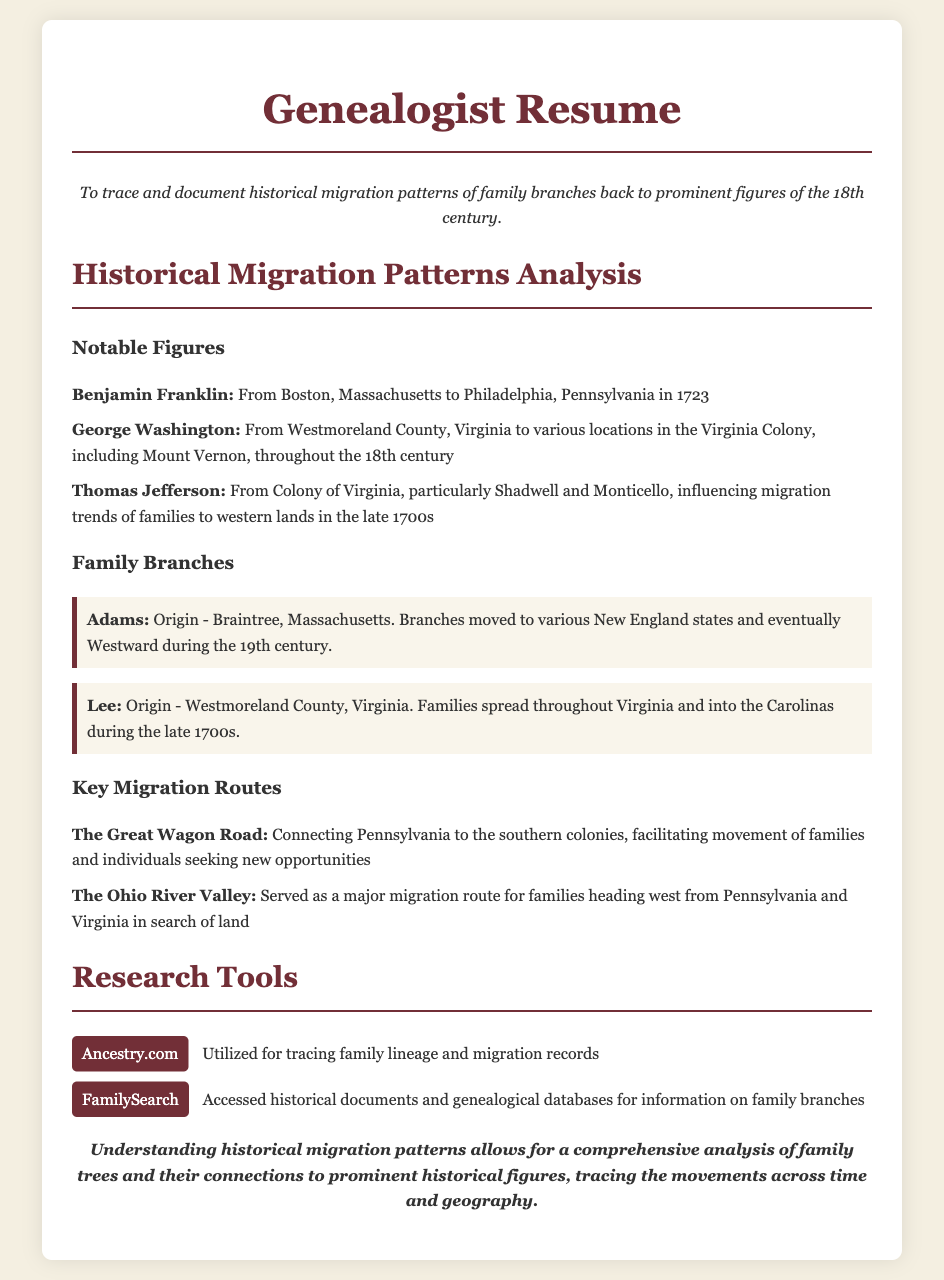what is the objective of the resume? The objective outlines the purpose of the resume, highlighting the genealogist's aim to trace and document historical migration patterns.
Answer: To trace and document historical migration patterns of family branches back to prominent figures of the 18th century who is mentioned as moving from Boston to Philadelphia? This information is specific to Benjamin Franklin, describing his migration path.
Answer: Benjamin Franklin which family branch originated from Braintree, Massachusetts? This question targets the origin of the Adams family, as noted in the document.
Answer: Adams what route connected Pennsylvania to the southern colonies? The question refers to a key migration route mentioned, providing historical context.
Answer: The Great Wagon Road which state did the Lee family primarily spread into during the late 1700s? This question addresses the geographic spread of the Lee family based on the document's information.
Answer: Carolinas how many notable figures are listed in the document? The question seeks to quantify the notable figures mentioned, emphasizing the list provided.
Answer: Three what tool is mentioned for tracing family lineage? This question focuses on identifying one of the research tools utilized for genealogical research.
Answer: Ancestry.com which prominent figure influenced migration trends to western lands? The focus here is on Thomas Jefferson's impact, as noted in the document's descriptions.
Answer: Thomas Jefferson what is the overarching theme of the conclusion? This question asks for the main message or insight conveyed in the concluding remarks of the document.
Answer: Comprehensive analysis of family trees and connections 